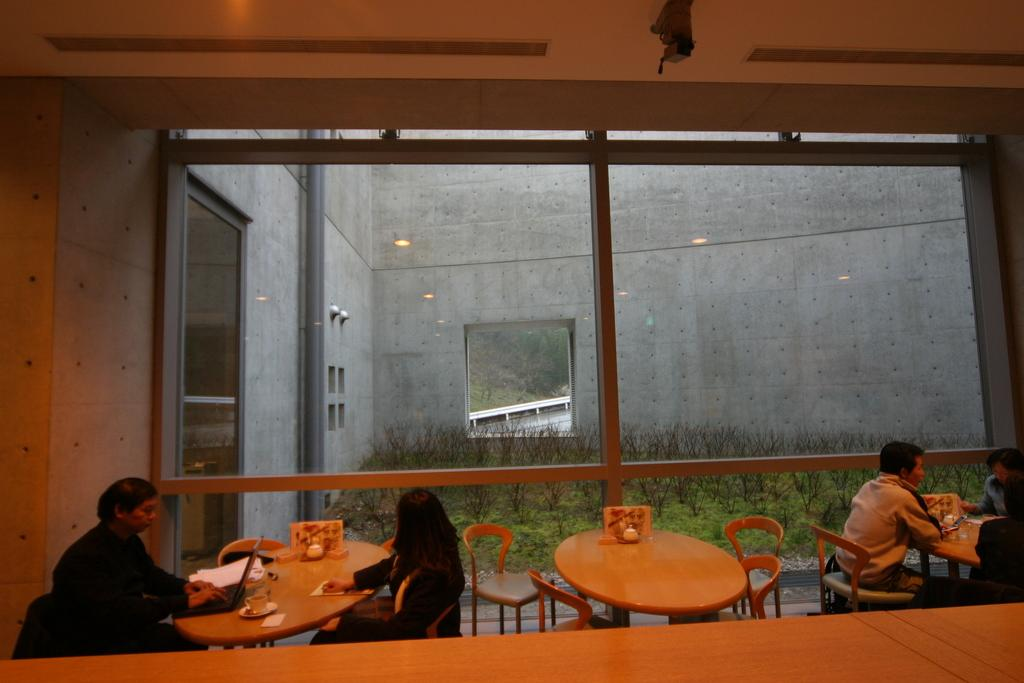What are the people in the image doing? The people in the image are sitting on chairs. What furniture is present in the image besides chairs? There are tables in the image. What type of vegetation is visible in the image? There are plants in the image. What electronic device is on a table in the image? There is a laptop on a table in the image. Where is the crib located in the image? There is no crib present in the image. What type of stove is visible in the image? There is no stove present in the image. 